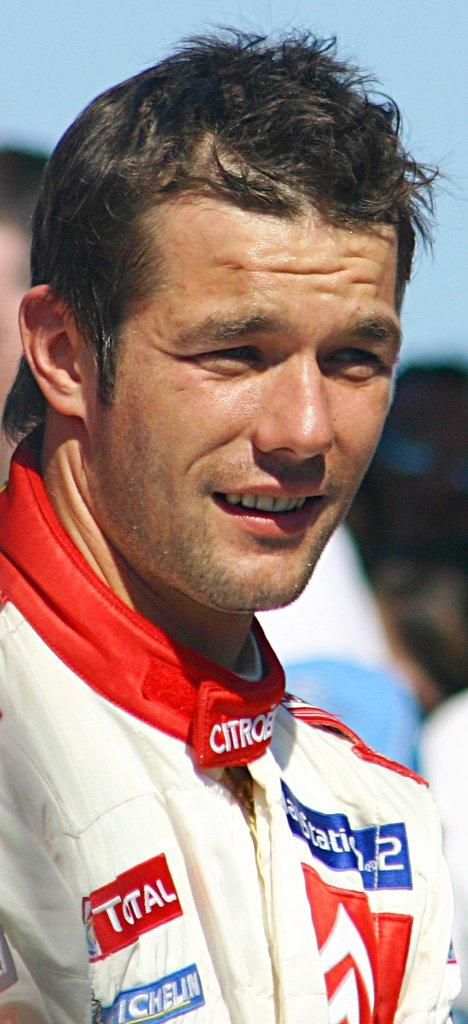<image>
Present a compact description of the photo's key features. Citroen is patched onto this driver's race uniform. 